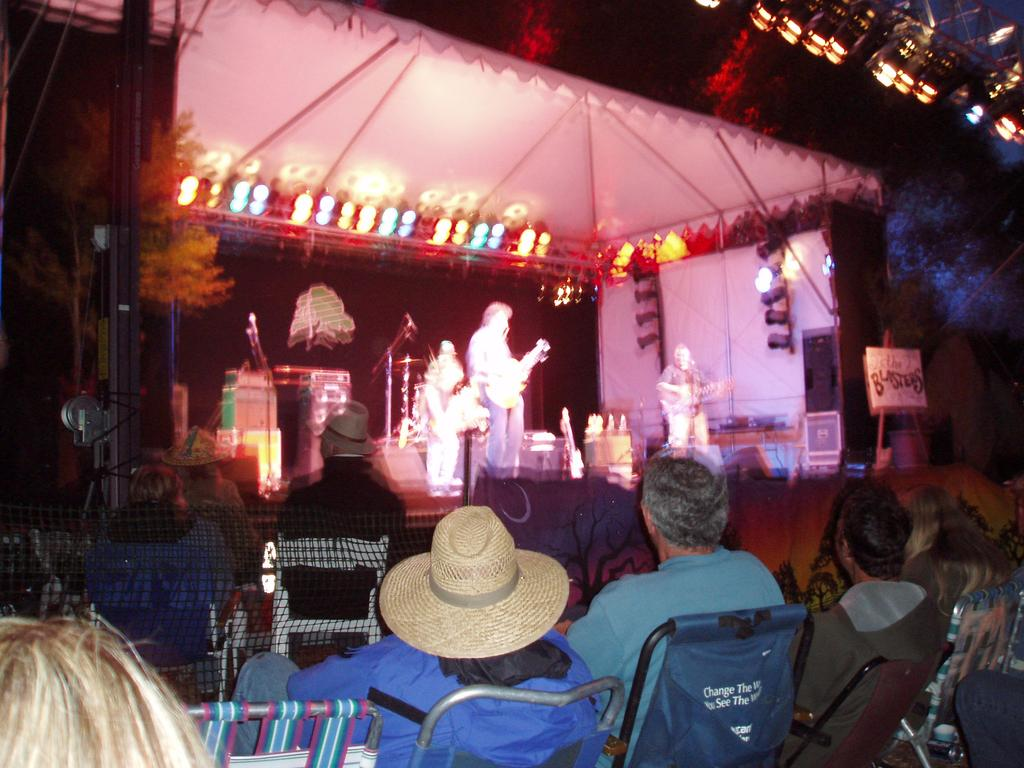What are the persons on the stage doing? The persons on the stage are playing music instruments. Who is present in the audience in front of the stage? There are audience members sitting in front of the stage. What type of pain is the audience experiencing during the performance? There is no indication of pain in the image, and it is not possible to determine the audience's emotional state from the image alone. What type of education is being provided to the audience during the performance? There is no indication of an educational component in the image; it simply shows persons playing music instruments on stage and audience members sitting in front of the stage. 